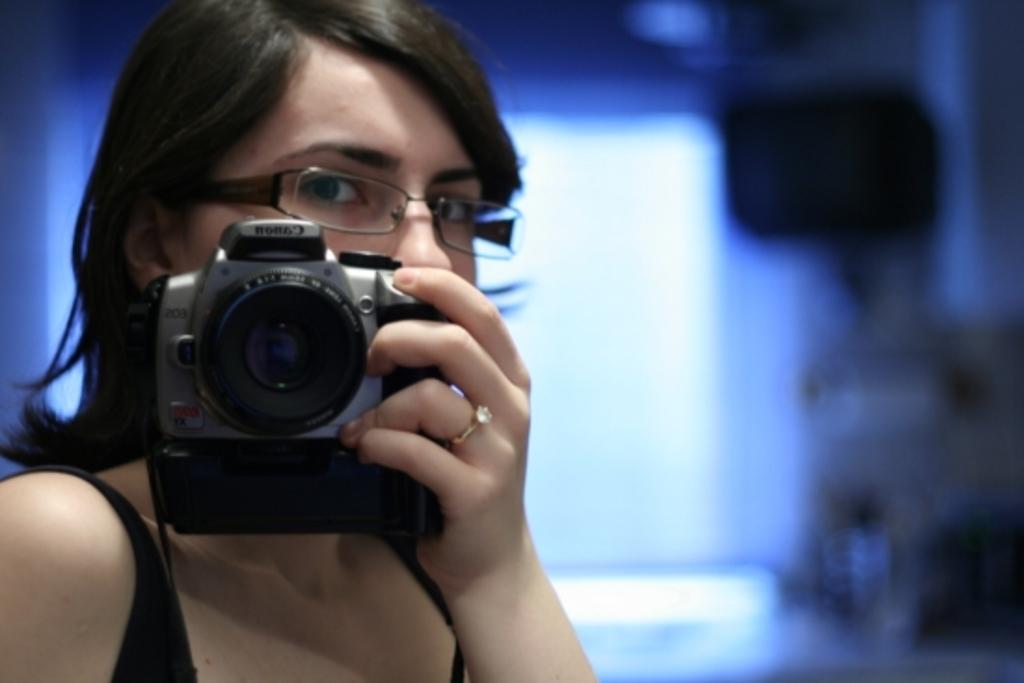Who is the main subject in the image? There is a woman in the image. What is the woman holding in her hands? The woman is holding a camera in her hands. What accessory is the woman wearing on her face? The woman is wearing spectacles. What color is the wall in the background of the image? There is a blue wall in the background of the image. What color is the woman's t-shirt? The woman is wearing a black t-shirt. Are there any chickens visible on the farm in the image? There is no farm or chickens present in the image; it features a woman holding a camera in front of a blue wall. 